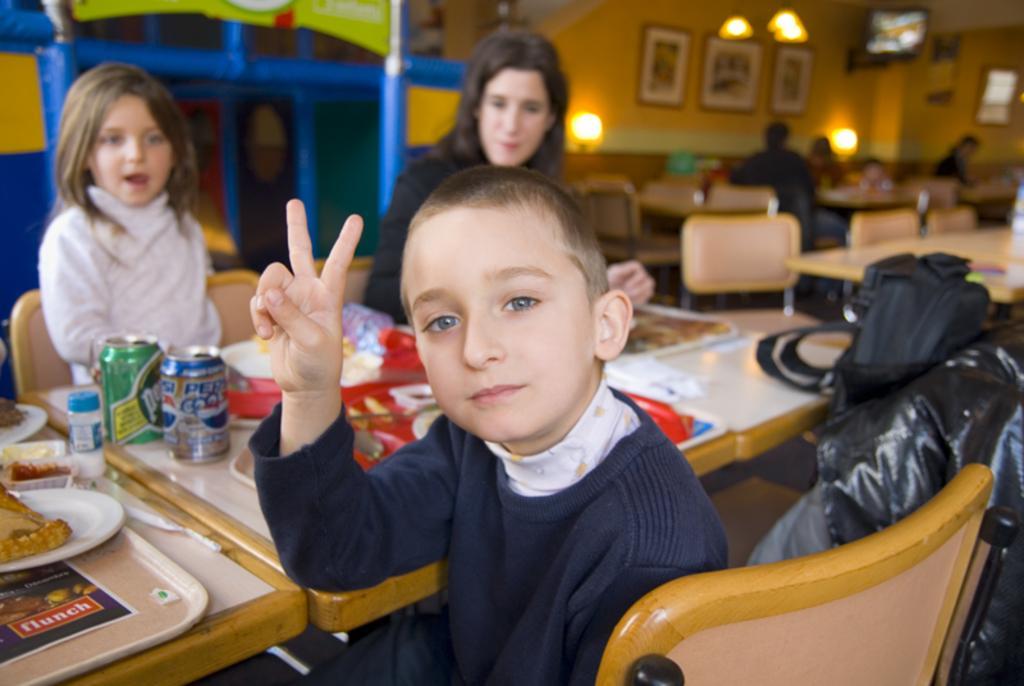Can you describe this image briefly? This picture describe about the inner view of the restaurant in which on the front table a boy is sitting wearing blue sweatshirt and on the behind her we can see woman and beside her a small girl wearing white T-shirt, and the behind we see a yellow wall on which three photo frames are placed. 